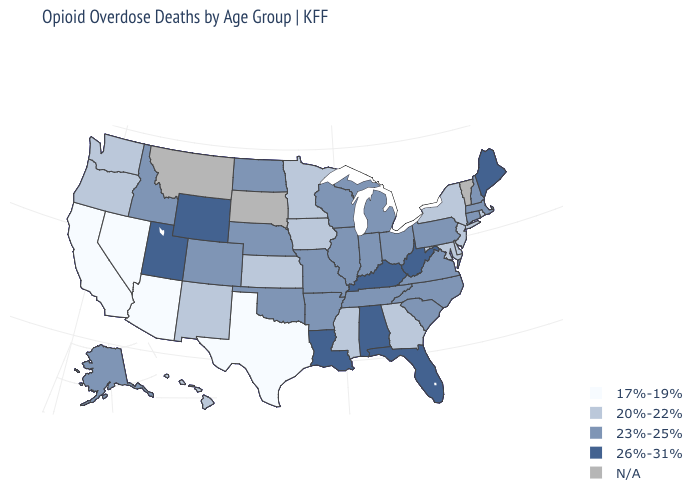Name the states that have a value in the range 20%-22%?
Concise answer only. Delaware, Georgia, Hawaii, Iowa, Kansas, Maryland, Minnesota, Mississippi, New Jersey, New Mexico, New York, Oregon, Rhode Island, Washington. Name the states that have a value in the range 23%-25%?
Concise answer only. Alaska, Arkansas, Colorado, Connecticut, Idaho, Illinois, Indiana, Massachusetts, Michigan, Missouri, Nebraska, New Hampshire, North Carolina, North Dakota, Ohio, Oklahoma, Pennsylvania, South Carolina, Tennessee, Virginia, Wisconsin. Does the first symbol in the legend represent the smallest category?
Short answer required. Yes. What is the highest value in the USA?
Short answer required. 26%-31%. What is the highest value in the USA?
Keep it brief. 26%-31%. Name the states that have a value in the range 23%-25%?
Write a very short answer. Alaska, Arkansas, Colorado, Connecticut, Idaho, Illinois, Indiana, Massachusetts, Michigan, Missouri, Nebraska, New Hampshire, North Carolina, North Dakota, Ohio, Oklahoma, Pennsylvania, South Carolina, Tennessee, Virginia, Wisconsin. What is the value of South Dakota?
Be succinct. N/A. What is the value of West Virginia?
Keep it brief. 26%-31%. Name the states that have a value in the range 20%-22%?
Short answer required. Delaware, Georgia, Hawaii, Iowa, Kansas, Maryland, Minnesota, Mississippi, New Jersey, New Mexico, New York, Oregon, Rhode Island, Washington. Does Louisiana have the highest value in the USA?
Be succinct. Yes. What is the value of Wyoming?
Keep it brief. 26%-31%. Which states have the lowest value in the USA?
Be succinct. Arizona, California, Nevada, Texas. What is the highest value in the West ?
Quick response, please. 26%-31%. What is the highest value in the MidWest ?
Quick response, please. 23%-25%. How many symbols are there in the legend?
Concise answer only. 5. 